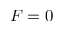<formula> <loc_0><loc_0><loc_500><loc_500>F = 0</formula> 